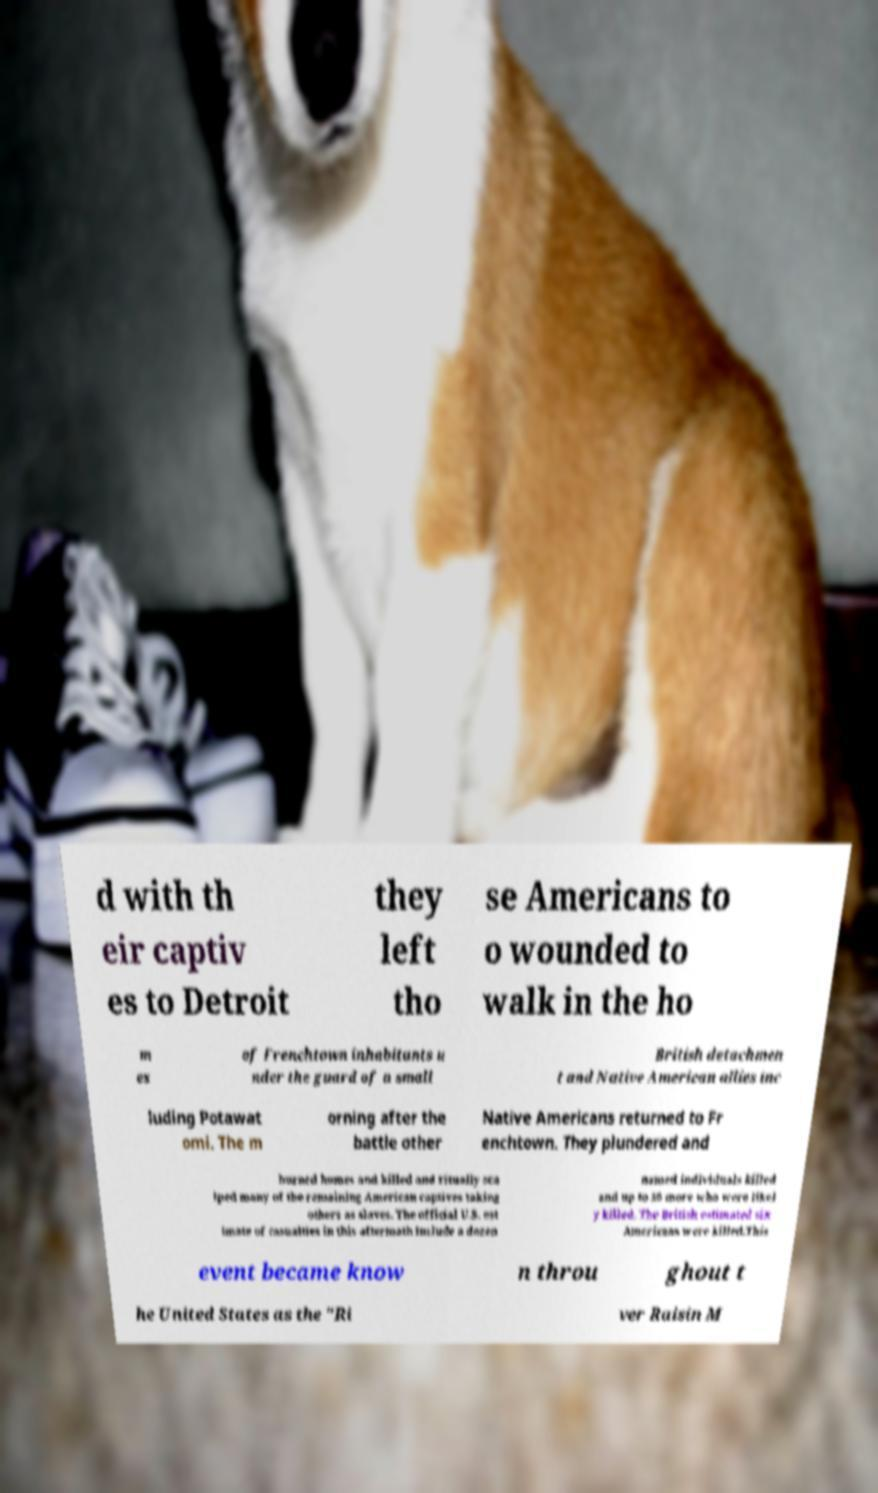For documentation purposes, I need the text within this image transcribed. Could you provide that? d with th eir captiv es to Detroit they left tho se Americans to o wounded to walk in the ho m es of Frenchtown inhabitants u nder the guard of a small British detachmen t and Native American allies inc luding Potawat omi. The m orning after the battle other Native Americans returned to Fr enchtown. They plundered and burned homes and killed and ritually sca lped many of the remaining American captives taking others as slaves. The official U.S. est imate of casualties in this aftermath include a dozen named individuals killed and up to 30 more who were likel y killed. The British estimated six Americans were killed.This event became know n throu ghout t he United States as the "Ri ver Raisin M 